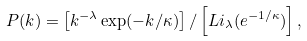Convert formula to latex. <formula><loc_0><loc_0><loc_500><loc_500>P ( k ) = \left [ k ^ { - \lambda } \exp ( - k / \kappa ) \right ] / \left [ L i _ { \lambda } ( e ^ { - 1 / \kappa } ) \right ] ,</formula> 